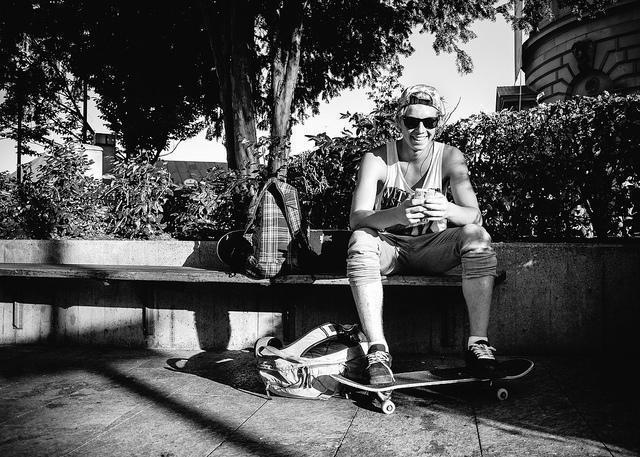What's the man taking a break from?
Make your selection and explain in format: 'Answer: answer
Rationale: rationale.'
Options: Skateboarding, wrestling, basketball, volleyball. Answer: skateboarding.
Rationale: The man is sitting with his skateboard on a bench and taking a break., 